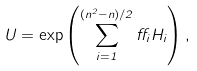Convert formula to latex. <formula><loc_0><loc_0><loc_500><loc_500>U = \exp \left ( \sum _ { i = 1 } ^ { ( n ^ { 2 } - n ) / 2 } \alpha _ { i } { H _ { i } } \right ) ,</formula> 